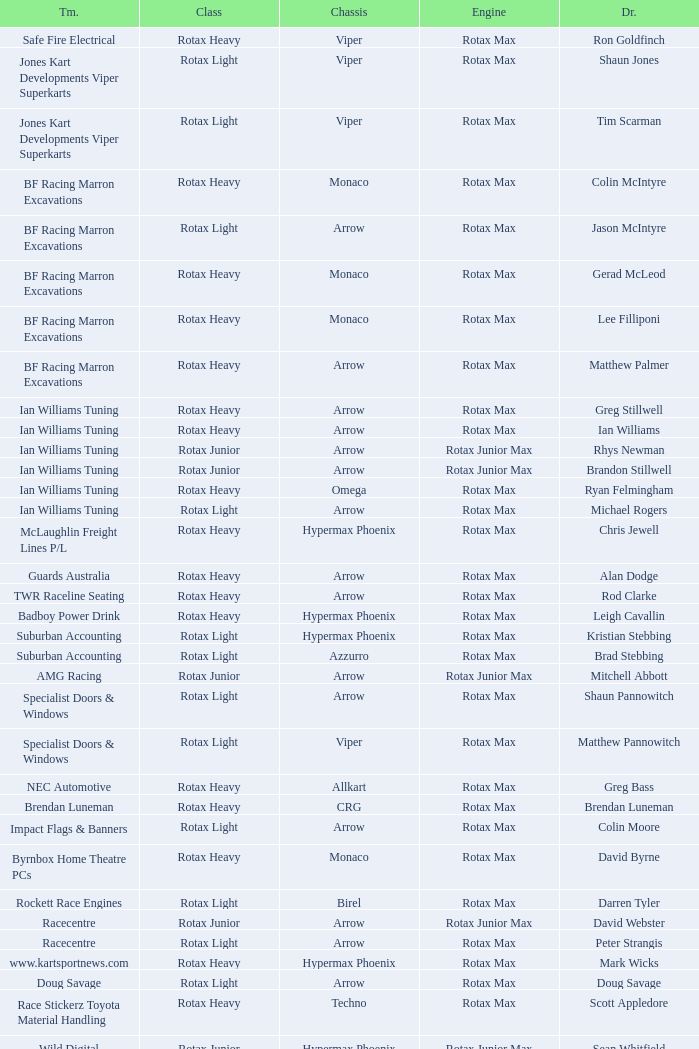What is the name of the team whose class is Rotax Light? Jones Kart Developments Viper Superkarts, Jones Kart Developments Viper Superkarts, BF Racing Marron Excavations, Ian Williams Tuning, Suburban Accounting, Suburban Accounting, Specialist Doors & Windows, Specialist Doors & Windows, Impact Flags & Banners, Rockett Race Engines, Racecentre, Doug Savage. 